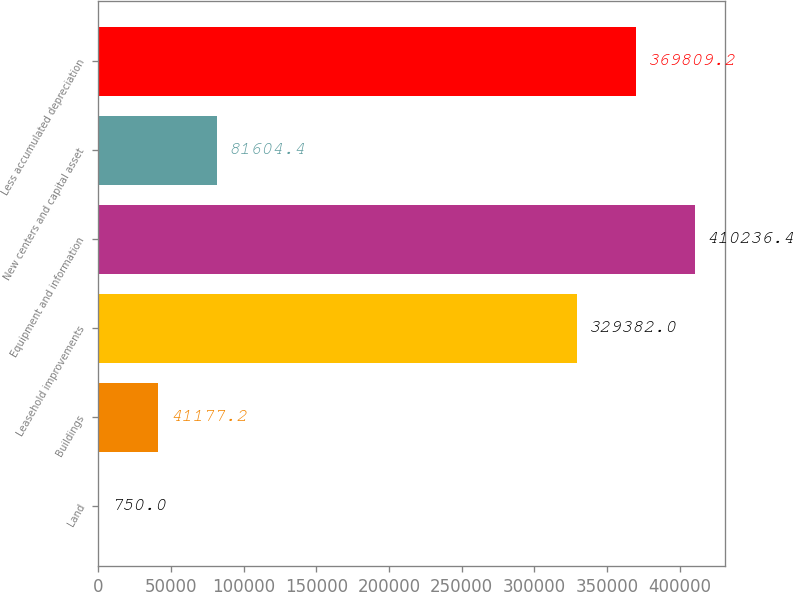Convert chart. <chart><loc_0><loc_0><loc_500><loc_500><bar_chart><fcel>Land<fcel>Buildings<fcel>Leasehold improvements<fcel>Equipment and information<fcel>New centers and capital asset<fcel>Less accumulated depreciation<nl><fcel>750<fcel>41177.2<fcel>329382<fcel>410236<fcel>81604.4<fcel>369809<nl></chart> 